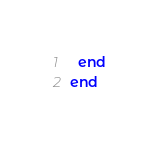Convert code to text. <code><loc_0><loc_0><loc_500><loc_500><_Ruby_>  end
end
</code> 